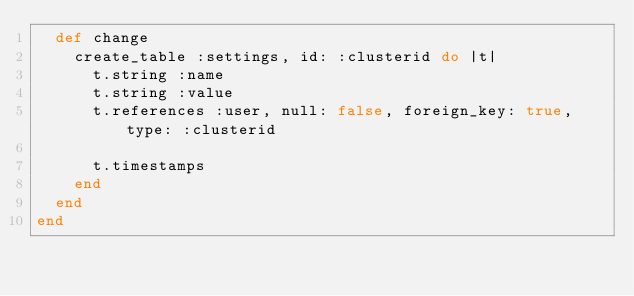<code> <loc_0><loc_0><loc_500><loc_500><_Ruby_>  def change
    create_table :settings, id: :clusterid do |t|
      t.string :name
      t.string :value
      t.references :user, null: false, foreign_key: true, type: :clusterid

      t.timestamps
    end
  end
end
</code> 